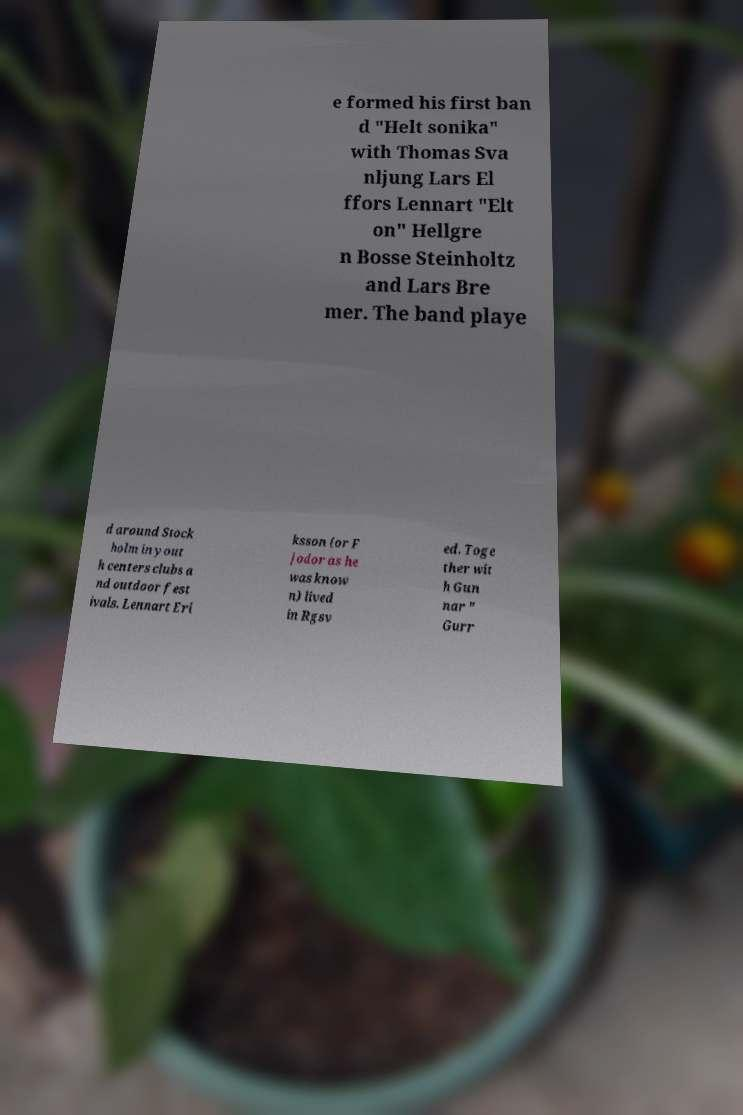For documentation purposes, I need the text within this image transcribed. Could you provide that? e formed his first ban d "Helt sonika" with Thomas Sva nljung Lars El ffors Lennart "Elt on" Hellgre n Bosse Steinholtz and Lars Bre mer. The band playe d around Stock holm in yout h centers clubs a nd outdoor fest ivals. Lennart Eri ksson (or F jodor as he was know n) lived in Rgsv ed. Toge ther wit h Gun nar " Gurr 